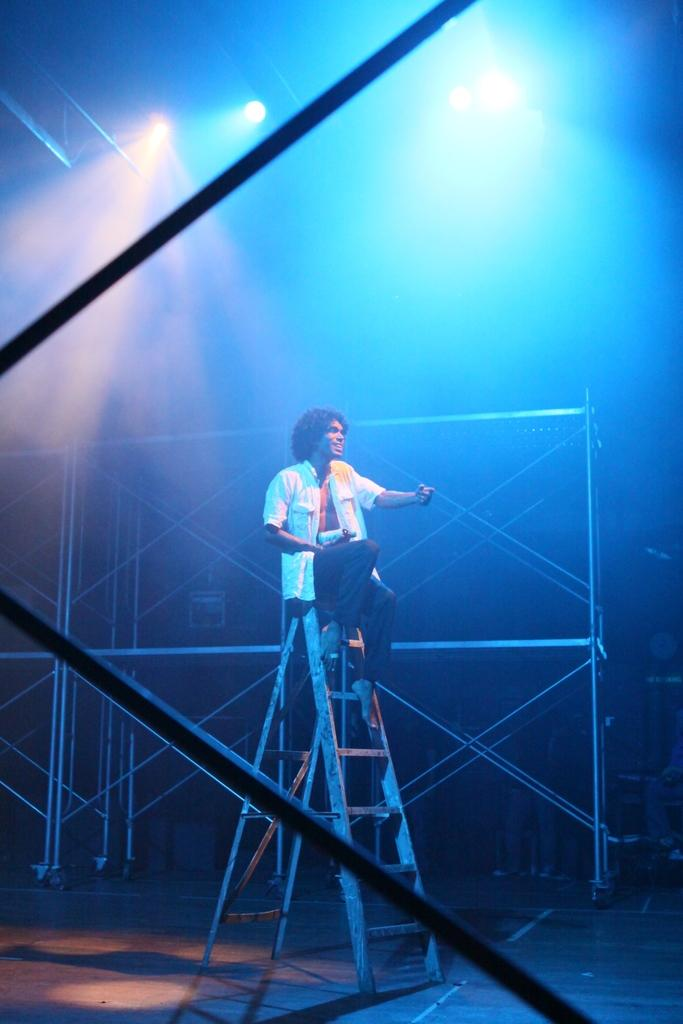What is the person in the image doing? The person is sitting on a ladder in the image. What is the person wearing? The person is wearing a white shirt and black pants. What is the person holding in the image? The person is holding an object. What can be seen in the background of the image? There are poles and lights visible in the background of the image. Can you see the ocean in the background of the image? No, there is no ocean visible in the background of the image. What type of curtain is hanging from the poles in the background? There are no curtains present in the image; only poles and lights are visible in the background. 